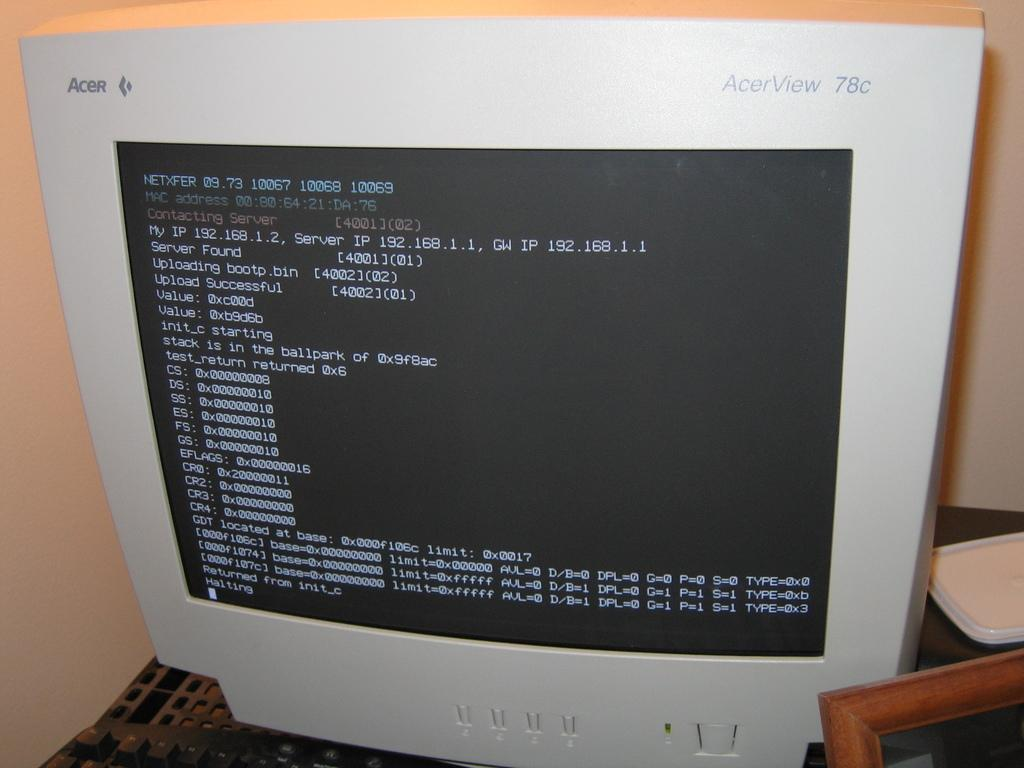<image>
Provide a brief description of the given image. An AcerView 78C compute rmonitor displays several lines of code. 